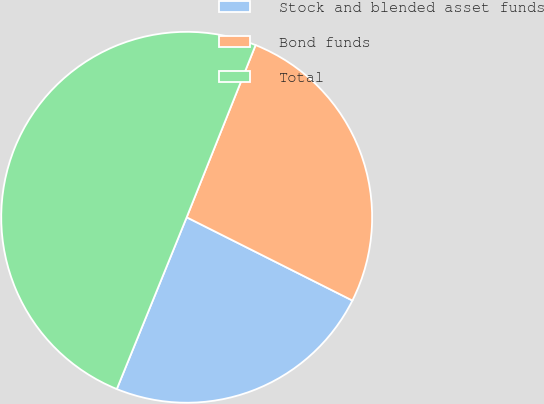<chart> <loc_0><loc_0><loc_500><loc_500><pie_chart><fcel>Stock and blended asset funds<fcel>Bond funds<fcel>Total<nl><fcel>23.74%<fcel>26.35%<fcel>49.91%<nl></chart> 